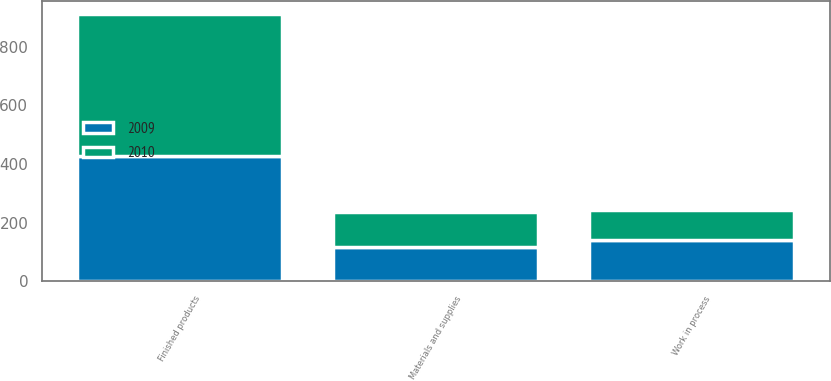Convert chart to OTSL. <chart><loc_0><loc_0><loc_500><loc_500><stacked_bar_chart><ecel><fcel>Materials and supplies<fcel>Work in process<fcel>Finished products<nl><fcel>2010<fcel>116.8<fcel>101<fcel>483.8<nl><fcel>2009<fcel>118.5<fcel>141.6<fcel>428.1<nl></chart> 